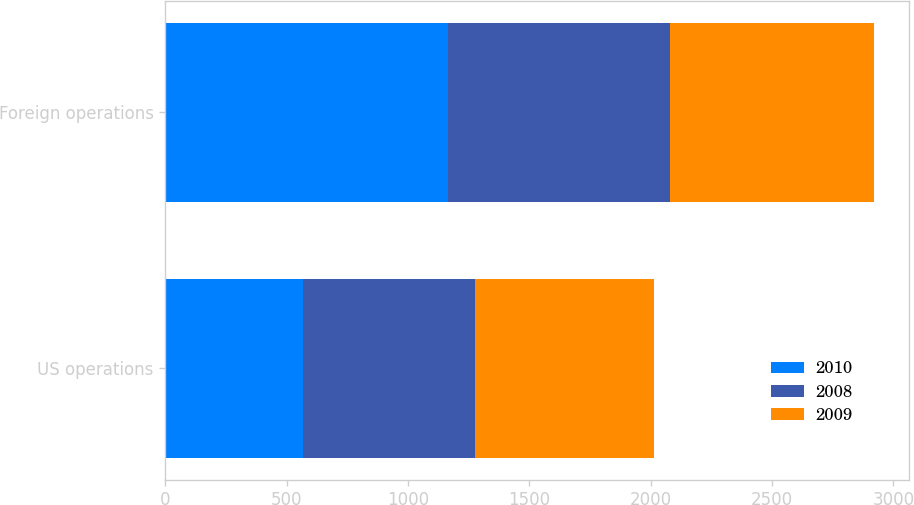Convert chart. <chart><loc_0><loc_0><loc_500><loc_500><stacked_bar_chart><ecel><fcel>US operations<fcel>Foreign operations<nl><fcel>2010<fcel>566<fcel>1163.6<nl><fcel>2008<fcel>709.5<fcel>914.4<nl><fcel>2009<fcel>738.1<fcel>842.1<nl></chart> 